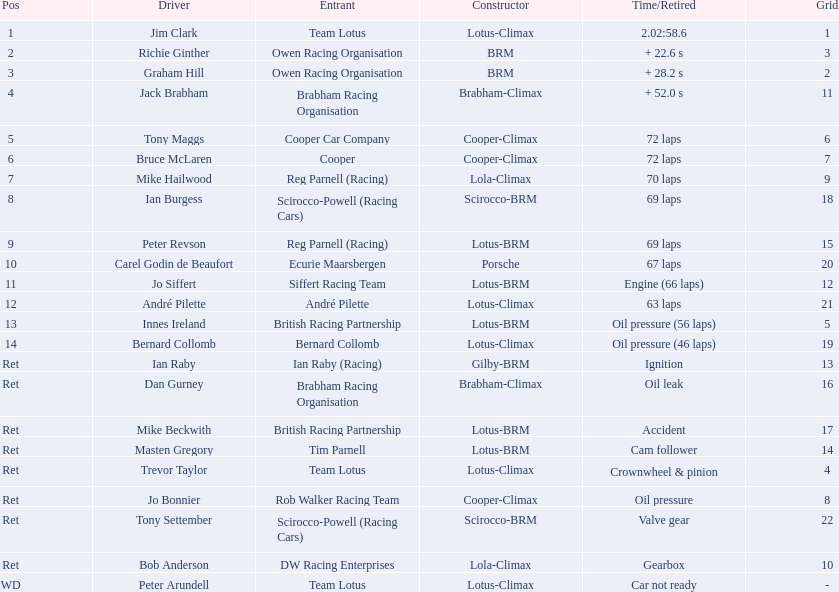Who participated as drivers in the 1963 international gold cup? Jim Clark, Richie Ginther, Graham Hill, Jack Brabham, Tony Maggs, Bruce McLaren, Mike Hailwood, Ian Burgess, Peter Revson, Carel Godin de Beaufort, Jo Siffert, André Pilette, Innes Ireland, Bernard Collomb, Ian Raby, Dan Gurney, Mike Beckwith, Masten Gregory, Trevor Taylor, Jo Bonnier, Tony Settember, Bob Anderson, Peter Arundell. What place did tony maggs secure? 5. What about jo siffert? 11. Which one of them finished earlier? Tony Maggs. 